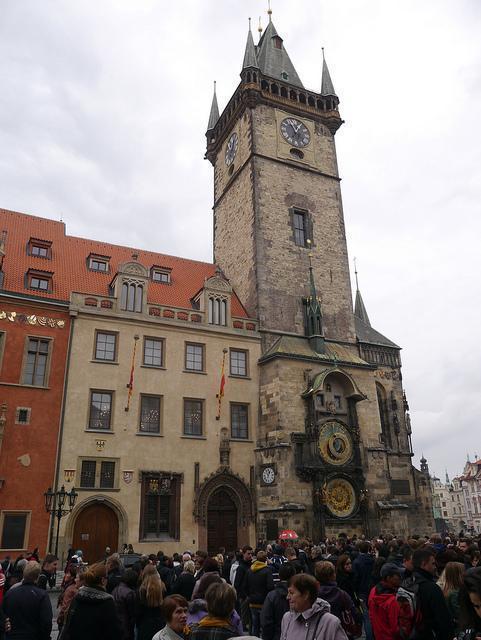What is the black circular object near the top of the tower used for?
Select the correct answer and articulate reasoning with the following format: 'Answer: answer
Rationale: rationale.'
Options: Telling time, cooking pizza, feeding birds, looking out. Answer: telling time.
Rationale: The circular object is a clock. 